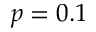<formula> <loc_0><loc_0><loc_500><loc_500>p = 0 . 1</formula> 